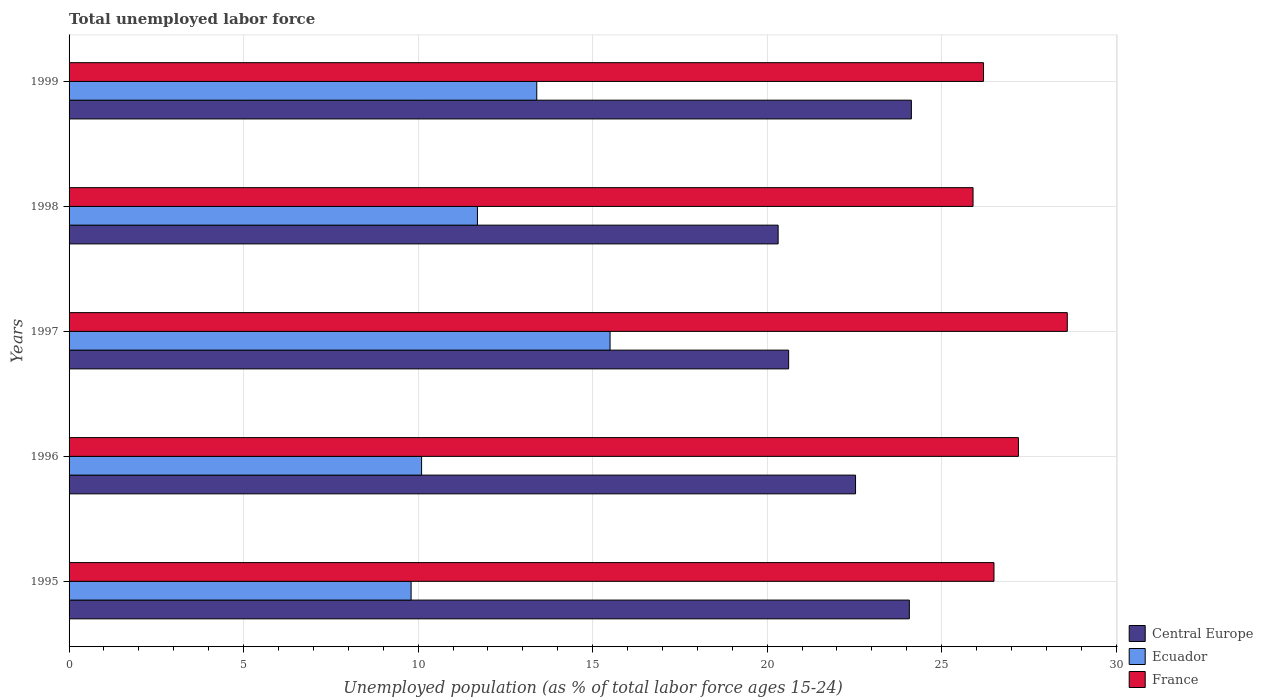How many different coloured bars are there?
Provide a short and direct response. 3. Are the number of bars per tick equal to the number of legend labels?
Ensure brevity in your answer.  Yes. In how many cases, is the number of bars for a given year not equal to the number of legend labels?
Provide a short and direct response. 0. What is the percentage of unemployed population in in France in 1997?
Offer a very short reply. 28.6. Across all years, what is the maximum percentage of unemployed population in in France?
Your response must be concise. 28.6. Across all years, what is the minimum percentage of unemployed population in in Central Europe?
Make the answer very short. 20.32. In which year was the percentage of unemployed population in in France minimum?
Keep it short and to the point. 1998. What is the total percentage of unemployed population in in Ecuador in the graph?
Give a very brief answer. 60.5. What is the difference between the percentage of unemployed population in in Central Europe in 1997 and that in 1999?
Keep it short and to the point. -3.52. What is the difference between the percentage of unemployed population in in France in 1998 and the percentage of unemployed population in in Ecuador in 1995?
Keep it short and to the point. 16.1. What is the average percentage of unemployed population in in Central Europe per year?
Give a very brief answer. 22.33. In the year 1996, what is the difference between the percentage of unemployed population in in France and percentage of unemployed population in in Central Europe?
Offer a terse response. 4.67. What is the ratio of the percentage of unemployed population in in Ecuador in 1997 to that in 1998?
Your response must be concise. 1.32. What is the difference between the highest and the second highest percentage of unemployed population in in Ecuador?
Keep it short and to the point. 2.1. What is the difference between the highest and the lowest percentage of unemployed population in in Central Europe?
Provide a short and direct response. 3.82. Is the sum of the percentage of unemployed population in in France in 1996 and 1998 greater than the maximum percentage of unemployed population in in Central Europe across all years?
Offer a terse response. Yes. What does the 1st bar from the top in 1998 represents?
Your answer should be compact. France. What does the 3rd bar from the bottom in 1999 represents?
Provide a short and direct response. France. Are all the bars in the graph horizontal?
Ensure brevity in your answer.  Yes. How many years are there in the graph?
Make the answer very short. 5. What is the difference between two consecutive major ticks on the X-axis?
Your answer should be compact. 5. Does the graph contain grids?
Provide a succinct answer. Yes. How are the legend labels stacked?
Your response must be concise. Vertical. What is the title of the graph?
Ensure brevity in your answer.  Total unemployed labor force. What is the label or title of the X-axis?
Offer a terse response. Unemployed population (as % of total labor force ages 15-24). What is the label or title of the Y-axis?
Ensure brevity in your answer.  Years. What is the Unemployed population (as % of total labor force ages 15-24) in Central Europe in 1995?
Offer a terse response. 24.07. What is the Unemployed population (as % of total labor force ages 15-24) in Ecuador in 1995?
Give a very brief answer. 9.8. What is the Unemployed population (as % of total labor force ages 15-24) in Central Europe in 1996?
Provide a succinct answer. 22.53. What is the Unemployed population (as % of total labor force ages 15-24) in Ecuador in 1996?
Your response must be concise. 10.1. What is the Unemployed population (as % of total labor force ages 15-24) in France in 1996?
Your answer should be very brief. 27.2. What is the Unemployed population (as % of total labor force ages 15-24) of Central Europe in 1997?
Give a very brief answer. 20.62. What is the Unemployed population (as % of total labor force ages 15-24) in France in 1997?
Offer a very short reply. 28.6. What is the Unemployed population (as % of total labor force ages 15-24) in Central Europe in 1998?
Your answer should be very brief. 20.32. What is the Unemployed population (as % of total labor force ages 15-24) of Ecuador in 1998?
Provide a short and direct response. 11.7. What is the Unemployed population (as % of total labor force ages 15-24) of France in 1998?
Give a very brief answer. 25.9. What is the Unemployed population (as % of total labor force ages 15-24) of Central Europe in 1999?
Your answer should be very brief. 24.13. What is the Unemployed population (as % of total labor force ages 15-24) in Ecuador in 1999?
Your answer should be compact. 13.4. What is the Unemployed population (as % of total labor force ages 15-24) in France in 1999?
Your answer should be very brief. 26.2. Across all years, what is the maximum Unemployed population (as % of total labor force ages 15-24) of Central Europe?
Your answer should be very brief. 24.13. Across all years, what is the maximum Unemployed population (as % of total labor force ages 15-24) in France?
Make the answer very short. 28.6. Across all years, what is the minimum Unemployed population (as % of total labor force ages 15-24) in Central Europe?
Your response must be concise. 20.32. Across all years, what is the minimum Unemployed population (as % of total labor force ages 15-24) in Ecuador?
Provide a short and direct response. 9.8. Across all years, what is the minimum Unemployed population (as % of total labor force ages 15-24) in France?
Give a very brief answer. 25.9. What is the total Unemployed population (as % of total labor force ages 15-24) in Central Europe in the graph?
Your answer should be compact. 111.67. What is the total Unemployed population (as % of total labor force ages 15-24) in Ecuador in the graph?
Offer a very short reply. 60.5. What is the total Unemployed population (as % of total labor force ages 15-24) of France in the graph?
Provide a succinct answer. 134.4. What is the difference between the Unemployed population (as % of total labor force ages 15-24) in Central Europe in 1995 and that in 1996?
Make the answer very short. 1.54. What is the difference between the Unemployed population (as % of total labor force ages 15-24) of Central Europe in 1995 and that in 1997?
Provide a short and direct response. 3.46. What is the difference between the Unemployed population (as % of total labor force ages 15-24) of Central Europe in 1995 and that in 1998?
Your answer should be very brief. 3.76. What is the difference between the Unemployed population (as % of total labor force ages 15-24) of France in 1995 and that in 1998?
Provide a succinct answer. 0.6. What is the difference between the Unemployed population (as % of total labor force ages 15-24) of Central Europe in 1995 and that in 1999?
Your answer should be very brief. -0.06. What is the difference between the Unemployed population (as % of total labor force ages 15-24) of France in 1995 and that in 1999?
Ensure brevity in your answer.  0.3. What is the difference between the Unemployed population (as % of total labor force ages 15-24) of Central Europe in 1996 and that in 1997?
Make the answer very short. 1.92. What is the difference between the Unemployed population (as % of total labor force ages 15-24) in Ecuador in 1996 and that in 1997?
Keep it short and to the point. -5.4. What is the difference between the Unemployed population (as % of total labor force ages 15-24) of Central Europe in 1996 and that in 1998?
Provide a succinct answer. 2.22. What is the difference between the Unemployed population (as % of total labor force ages 15-24) of Ecuador in 1996 and that in 1998?
Your response must be concise. -1.6. What is the difference between the Unemployed population (as % of total labor force ages 15-24) of France in 1996 and that in 1998?
Provide a short and direct response. 1.3. What is the difference between the Unemployed population (as % of total labor force ages 15-24) in Central Europe in 1996 and that in 1999?
Provide a succinct answer. -1.6. What is the difference between the Unemployed population (as % of total labor force ages 15-24) in France in 1996 and that in 1999?
Provide a succinct answer. 1. What is the difference between the Unemployed population (as % of total labor force ages 15-24) in Central Europe in 1997 and that in 1998?
Ensure brevity in your answer.  0.3. What is the difference between the Unemployed population (as % of total labor force ages 15-24) of Ecuador in 1997 and that in 1998?
Your response must be concise. 3.8. What is the difference between the Unemployed population (as % of total labor force ages 15-24) of France in 1997 and that in 1998?
Keep it short and to the point. 2.7. What is the difference between the Unemployed population (as % of total labor force ages 15-24) of Central Europe in 1997 and that in 1999?
Your response must be concise. -3.52. What is the difference between the Unemployed population (as % of total labor force ages 15-24) in Ecuador in 1997 and that in 1999?
Your answer should be compact. 2.1. What is the difference between the Unemployed population (as % of total labor force ages 15-24) of France in 1997 and that in 1999?
Your answer should be compact. 2.4. What is the difference between the Unemployed population (as % of total labor force ages 15-24) in Central Europe in 1998 and that in 1999?
Provide a short and direct response. -3.82. What is the difference between the Unemployed population (as % of total labor force ages 15-24) in Ecuador in 1998 and that in 1999?
Ensure brevity in your answer.  -1.7. What is the difference between the Unemployed population (as % of total labor force ages 15-24) in Central Europe in 1995 and the Unemployed population (as % of total labor force ages 15-24) in Ecuador in 1996?
Make the answer very short. 13.97. What is the difference between the Unemployed population (as % of total labor force ages 15-24) in Central Europe in 1995 and the Unemployed population (as % of total labor force ages 15-24) in France in 1996?
Make the answer very short. -3.13. What is the difference between the Unemployed population (as % of total labor force ages 15-24) in Ecuador in 1995 and the Unemployed population (as % of total labor force ages 15-24) in France in 1996?
Ensure brevity in your answer.  -17.4. What is the difference between the Unemployed population (as % of total labor force ages 15-24) of Central Europe in 1995 and the Unemployed population (as % of total labor force ages 15-24) of Ecuador in 1997?
Keep it short and to the point. 8.57. What is the difference between the Unemployed population (as % of total labor force ages 15-24) of Central Europe in 1995 and the Unemployed population (as % of total labor force ages 15-24) of France in 1997?
Give a very brief answer. -4.53. What is the difference between the Unemployed population (as % of total labor force ages 15-24) in Ecuador in 1995 and the Unemployed population (as % of total labor force ages 15-24) in France in 1997?
Your answer should be compact. -18.8. What is the difference between the Unemployed population (as % of total labor force ages 15-24) of Central Europe in 1995 and the Unemployed population (as % of total labor force ages 15-24) of Ecuador in 1998?
Provide a succinct answer. 12.37. What is the difference between the Unemployed population (as % of total labor force ages 15-24) of Central Europe in 1995 and the Unemployed population (as % of total labor force ages 15-24) of France in 1998?
Offer a very short reply. -1.83. What is the difference between the Unemployed population (as % of total labor force ages 15-24) in Ecuador in 1995 and the Unemployed population (as % of total labor force ages 15-24) in France in 1998?
Your answer should be very brief. -16.1. What is the difference between the Unemployed population (as % of total labor force ages 15-24) of Central Europe in 1995 and the Unemployed population (as % of total labor force ages 15-24) of Ecuador in 1999?
Your answer should be compact. 10.67. What is the difference between the Unemployed population (as % of total labor force ages 15-24) in Central Europe in 1995 and the Unemployed population (as % of total labor force ages 15-24) in France in 1999?
Give a very brief answer. -2.13. What is the difference between the Unemployed population (as % of total labor force ages 15-24) in Ecuador in 1995 and the Unemployed population (as % of total labor force ages 15-24) in France in 1999?
Give a very brief answer. -16.4. What is the difference between the Unemployed population (as % of total labor force ages 15-24) of Central Europe in 1996 and the Unemployed population (as % of total labor force ages 15-24) of Ecuador in 1997?
Provide a succinct answer. 7.03. What is the difference between the Unemployed population (as % of total labor force ages 15-24) of Central Europe in 1996 and the Unemployed population (as % of total labor force ages 15-24) of France in 1997?
Provide a succinct answer. -6.07. What is the difference between the Unemployed population (as % of total labor force ages 15-24) of Ecuador in 1996 and the Unemployed population (as % of total labor force ages 15-24) of France in 1997?
Your answer should be very brief. -18.5. What is the difference between the Unemployed population (as % of total labor force ages 15-24) of Central Europe in 1996 and the Unemployed population (as % of total labor force ages 15-24) of Ecuador in 1998?
Keep it short and to the point. 10.83. What is the difference between the Unemployed population (as % of total labor force ages 15-24) in Central Europe in 1996 and the Unemployed population (as % of total labor force ages 15-24) in France in 1998?
Give a very brief answer. -3.37. What is the difference between the Unemployed population (as % of total labor force ages 15-24) in Ecuador in 1996 and the Unemployed population (as % of total labor force ages 15-24) in France in 1998?
Ensure brevity in your answer.  -15.8. What is the difference between the Unemployed population (as % of total labor force ages 15-24) in Central Europe in 1996 and the Unemployed population (as % of total labor force ages 15-24) in Ecuador in 1999?
Keep it short and to the point. 9.13. What is the difference between the Unemployed population (as % of total labor force ages 15-24) in Central Europe in 1996 and the Unemployed population (as % of total labor force ages 15-24) in France in 1999?
Provide a short and direct response. -3.67. What is the difference between the Unemployed population (as % of total labor force ages 15-24) in Ecuador in 1996 and the Unemployed population (as % of total labor force ages 15-24) in France in 1999?
Give a very brief answer. -16.1. What is the difference between the Unemployed population (as % of total labor force ages 15-24) in Central Europe in 1997 and the Unemployed population (as % of total labor force ages 15-24) in Ecuador in 1998?
Provide a succinct answer. 8.92. What is the difference between the Unemployed population (as % of total labor force ages 15-24) of Central Europe in 1997 and the Unemployed population (as % of total labor force ages 15-24) of France in 1998?
Make the answer very short. -5.28. What is the difference between the Unemployed population (as % of total labor force ages 15-24) in Ecuador in 1997 and the Unemployed population (as % of total labor force ages 15-24) in France in 1998?
Make the answer very short. -10.4. What is the difference between the Unemployed population (as % of total labor force ages 15-24) of Central Europe in 1997 and the Unemployed population (as % of total labor force ages 15-24) of Ecuador in 1999?
Make the answer very short. 7.22. What is the difference between the Unemployed population (as % of total labor force ages 15-24) in Central Europe in 1997 and the Unemployed population (as % of total labor force ages 15-24) in France in 1999?
Give a very brief answer. -5.58. What is the difference between the Unemployed population (as % of total labor force ages 15-24) of Ecuador in 1997 and the Unemployed population (as % of total labor force ages 15-24) of France in 1999?
Your response must be concise. -10.7. What is the difference between the Unemployed population (as % of total labor force ages 15-24) of Central Europe in 1998 and the Unemployed population (as % of total labor force ages 15-24) of Ecuador in 1999?
Offer a very short reply. 6.92. What is the difference between the Unemployed population (as % of total labor force ages 15-24) of Central Europe in 1998 and the Unemployed population (as % of total labor force ages 15-24) of France in 1999?
Ensure brevity in your answer.  -5.88. What is the difference between the Unemployed population (as % of total labor force ages 15-24) in Ecuador in 1998 and the Unemployed population (as % of total labor force ages 15-24) in France in 1999?
Make the answer very short. -14.5. What is the average Unemployed population (as % of total labor force ages 15-24) of Central Europe per year?
Keep it short and to the point. 22.33. What is the average Unemployed population (as % of total labor force ages 15-24) of France per year?
Make the answer very short. 26.88. In the year 1995, what is the difference between the Unemployed population (as % of total labor force ages 15-24) of Central Europe and Unemployed population (as % of total labor force ages 15-24) of Ecuador?
Your response must be concise. 14.27. In the year 1995, what is the difference between the Unemployed population (as % of total labor force ages 15-24) of Central Europe and Unemployed population (as % of total labor force ages 15-24) of France?
Offer a terse response. -2.43. In the year 1995, what is the difference between the Unemployed population (as % of total labor force ages 15-24) of Ecuador and Unemployed population (as % of total labor force ages 15-24) of France?
Provide a short and direct response. -16.7. In the year 1996, what is the difference between the Unemployed population (as % of total labor force ages 15-24) in Central Europe and Unemployed population (as % of total labor force ages 15-24) in Ecuador?
Offer a very short reply. 12.43. In the year 1996, what is the difference between the Unemployed population (as % of total labor force ages 15-24) in Central Europe and Unemployed population (as % of total labor force ages 15-24) in France?
Your answer should be very brief. -4.67. In the year 1996, what is the difference between the Unemployed population (as % of total labor force ages 15-24) of Ecuador and Unemployed population (as % of total labor force ages 15-24) of France?
Provide a succinct answer. -17.1. In the year 1997, what is the difference between the Unemployed population (as % of total labor force ages 15-24) in Central Europe and Unemployed population (as % of total labor force ages 15-24) in Ecuador?
Your answer should be very brief. 5.12. In the year 1997, what is the difference between the Unemployed population (as % of total labor force ages 15-24) of Central Europe and Unemployed population (as % of total labor force ages 15-24) of France?
Keep it short and to the point. -7.98. In the year 1998, what is the difference between the Unemployed population (as % of total labor force ages 15-24) in Central Europe and Unemployed population (as % of total labor force ages 15-24) in Ecuador?
Keep it short and to the point. 8.62. In the year 1998, what is the difference between the Unemployed population (as % of total labor force ages 15-24) of Central Europe and Unemployed population (as % of total labor force ages 15-24) of France?
Provide a short and direct response. -5.58. In the year 1998, what is the difference between the Unemployed population (as % of total labor force ages 15-24) in Ecuador and Unemployed population (as % of total labor force ages 15-24) in France?
Provide a succinct answer. -14.2. In the year 1999, what is the difference between the Unemployed population (as % of total labor force ages 15-24) in Central Europe and Unemployed population (as % of total labor force ages 15-24) in Ecuador?
Your response must be concise. 10.73. In the year 1999, what is the difference between the Unemployed population (as % of total labor force ages 15-24) of Central Europe and Unemployed population (as % of total labor force ages 15-24) of France?
Make the answer very short. -2.07. In the year 1999, what is the difference between the Unemployed population (as % of total labor force ages 15-24) in Ecuador and Unemployed population (as % of total labor force ages 15-24) in France?
Provide a short and direct response. -12.8. What is the ratio of the Unemployed population (as % of total labor force ages 15-24) of Central Europe in 1995 to that in 1996?
Make the answer very short. 1.07. What is the ratio of the Unemployed population (as % of total labor force ages 15-24) in Ecuador in 1995 to that in 1996?
Your answer should be compact. 0.97. What is the ratio of the Unemployed population (as % of total labor force ages 15-24) of France in 1995 to that in 1996?
Your response must be concise. 0.97. What is the ratio of the Unemployed population (as % of total labor force ages 15-24) of Central Europe in 1995 to that in 1997?
Your response must be concise. 1.17. What is the ratio of the Unemployed population (as % of total labor force ages 15-24) of Ecuador in 1995 to that in 1997?
Keep it short and to the point. 0.63. What is the ratio of the Unemployed population (as % of total labor force ages 15-24) in France in 1995 to that in 1997?
Your response must be concise. 0.93. What is the ratio of the Unemployed population (as % of total labor force ages 15-24) of Central Europe in 1995 to that in 1998?
Provide a short and direct response. 1.19. What is the ratio of the Unemployed population (as % of total labor force ages 15-24) in Ecuador in 1995 to that in 1998?
Give a very brief answer. 0.84. What is the ratio of the Unemployed population (as % of total labor force ages 15-24) of France in 1995 to that in 1998?
Offer a terse response. 1.02. What is the ratio of the Unemployed population (as % of total labor force ages 15-24) of Central Europe in 1995 to that in 1999?
Give a very brief answer. 1. What is the ratio of the Unemployed population (as % of total labor force ages 15-24) in Ecuador in 1995 to that in 1999?
Your answer should be compact. 0.73. What is the ratio of the Unemployed population (as % of total labor force ages 15-24) of France in 1995 to that in 1999?
Your answer should be very brief. 1.01. What is the ratio of the Unemployed population (as % of total labor force ages 15-24) of Central Europe in 1996 to that in 1997?
Keep it short and to the point. 1.09. What is the ratio of the Unemployed population (as % of total labor force ages 15-24) in Ecuador in 1996 to that in 1997?
Your answer should be very brief. 0.65. What is the ratio of the Unemployed population (as % of total labor force ages 15-24) of France in 1996 to that in 1997?
Offer a very short reply. 0.95. What is the ratio of the Unemployed population (as % of total labor force ages 15-24) in Central Europe in 1996 to that in 1998?
Your answer should be very brief. 1.11. What is the ratio of the Unemployed population (as % of total labor force ages 15-24) of Ecuador in 1996 to that in 1998?
Provide a short and direct response. 0.86. What is the ratio of the Unemployed population (as % of total labor force ages 15-24) of France in 1996 to that in 1998?
Your response must be concise. 1.05. What is the ratio of the Unemployed population (as % of total labor force ages 15-24) of Central Europe in 1996 to that in 1999?
Offer a terse response. 0.93. What is the ratio of the Unemployed population (as % of total labor force ages 15-24) of Ecuador in 1996 to that in 1999?
Give a very brief answer. 0.75. What is the ratio of the Unemployed population (as % of total labor force ages 15-24) of France in 1996 to that in 1999?
Ensure brevity in your answer.  1.04. What is the ratio of the Unemployed population (as % of total labor force ages 15-24) in Central Europe in 1997 to that in 1998?
Provide a succinct answer. 1.01. What is the ratio of the Unemployed population (as % of total labor force ages 15-24) in Ecuador in 1997 to that in 1998?
Provide a short and direct response. 1.32. What is the ratio of the Unemployed population (as % of total labor force ages 15-24) of France in 1997 to that in 1998?
Ensure brevity in your answer.  1.1. What is the ratio of the Unemployed population (as % of total labor force ages 15-24) of Central Europe in 1997 to that in 1999?
Your answer should be very brief. 0.85. What is the ratio of the Unemployed population (as % of total labor force ages 15-24) of Ecuador in 1997 to that in 1999?
Provide a succinct answer. 1.16. What is the ratio of the Unemployed population (as % of total labor force ages 15-24) of France in 1997 to that in 1999?
Your answer should be very brief. 1.09. What is the ratio of the Unemployed population (as % of total labor force ages 15-24) of Central Europe in 1998 to that in 1999?
Your answer should be compact. 0.84. What is the ratio of the Unemployed population (as % of total labor force ages 15-24) in Ecuador in 1998 to that in 1999?
Your answer should be compact. 0.87. What is the difference between the highest and the second highest Unemployed population (as % of total labor force ages 15-24) of Central Europe?
Your answer should be very brief. 0.06. What is the difference between the highest and the second highest Unemployed population (as % of total labor force ages 15-24) in France?
Provide a short and direct response. 1.4. What is the difference between the highest and the lowest Unemployed population (as % of total labor force ages 15-24) in Central Europe?
Keep it short and to the point. 3.82. What is the difference between the highest and the lowest Unemployed population (as % of total labor force ages 15-24) of Ecuador?
Provide a short and direct response. 5.7. What is the difference between the highest and the lowest Unemployed population (as % of total labor force ages 15-24) in France?
Provide a short and direct response. 2.7. 